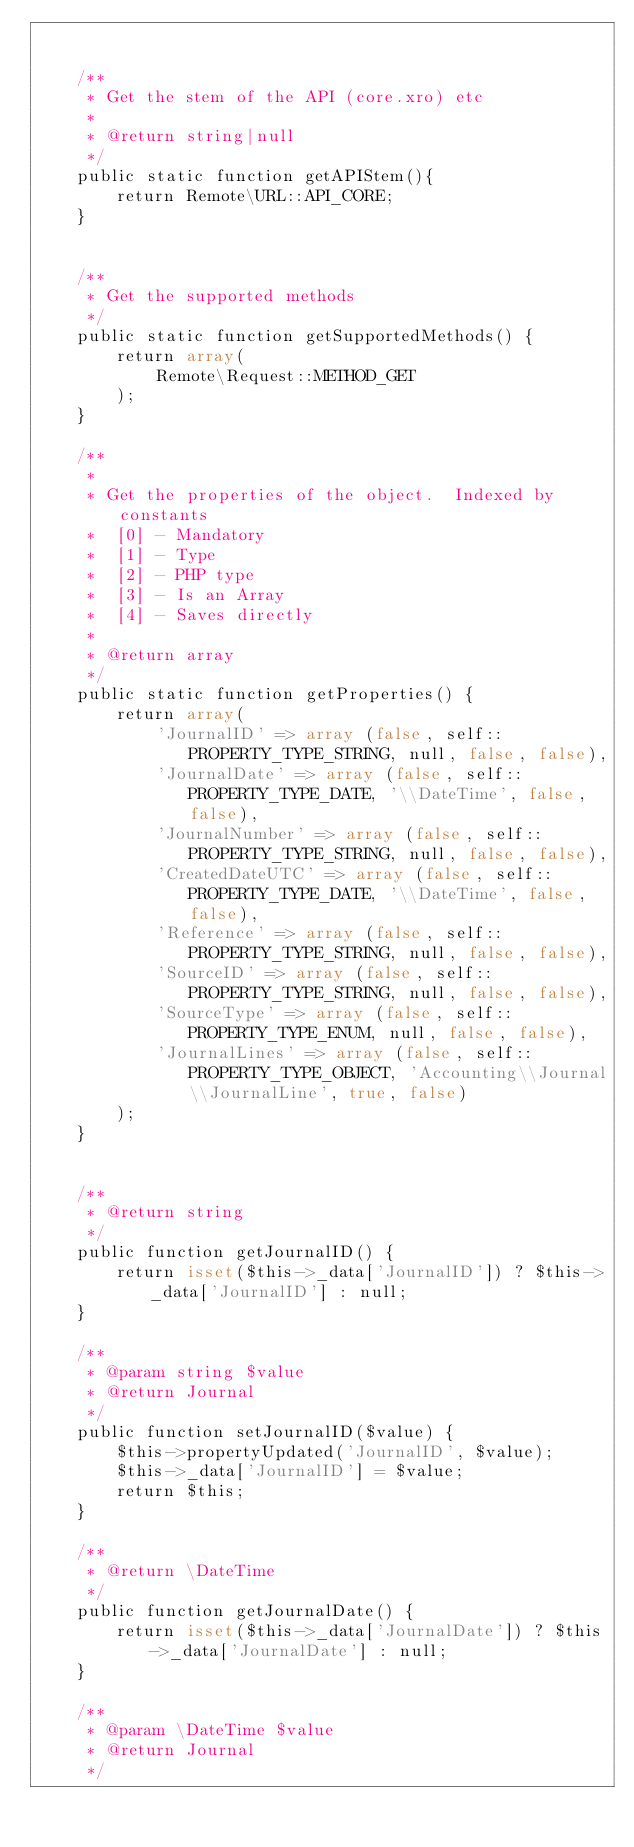Convert code to text. <code><loc_0><loc_0><loc_500><loc_500><_PHP_>

    /**
     * Get the stem of the API (core.xro) etc
     *
     * @return string|null
     */
    public static function getAPIStem(){
        return Remote\URL::API_CORE;
    }


    /**
     * Get the supported methods
     */
    public static function getSupportedMethods() {
        return array(
            Remote\Request::METHOD_GET
        );
    }

    /**
     *
     * Get the properties of the object.  Indexed by constants
     *  [0] - Mandatory
     *  [1] - Type
     *  [2] - PHP type
     *  [3] - Is an Array
     *  [4] - Saves directly
     *
     * @return array
     */
    public static function getProperties() {
        return array(
            'JournalID' => array (false, self::PROPERTY_TYPE_STRING, null, false, false),
            'JournalDate' => array (false, self::PROPERTY_TYPE_DATE, '\\DateTime', false, false),
            'JournalNumber' => array (false, self::PROPERTY_TYPE_STRING, null, false, false),
            'CreatedDateUTC' => array (false, self::PROPERTY_TYPE_DATE, '\\DateTime', false, false),
            'Reference' => array (false, self::PROPERTY_TYPE_STRING, null, false, false),
            'SourceID' => array (false, self::PROPERTY_TYPE_STRING, null, false, false),
            'SourceType' => array (false, self::PROPERTY_TYPE_ENUM, null, false, false),
            'JournalLines' => array (false, self::PROPERTY_TYPE_OBJECT, 'Accounting\\Journal\\JournalLine', true, false)
        );
    }


    /**
     * @return string
     */
    public function getJournalID() {
        return isset($this->_data['JournalID']) ? $this->_data['JournalID'] : null;
    }

    /**
     * @param string $value
     * @return Journal
     */
    public function setJournalID($value) {
        $this->propertyUpdated('JournalID', $value);
        $this->_data['JournalID'] = $value;
        return $this;
    }

    /**
     * @return \DateTime
     */
    public function getJournalDate() {
        return isset($this->_data['JournalDate']) ? $this->_data['JournalDate'] : null;
    }

    /**
     * @param \DateTime $value
     * @return Journal
     */</code> 